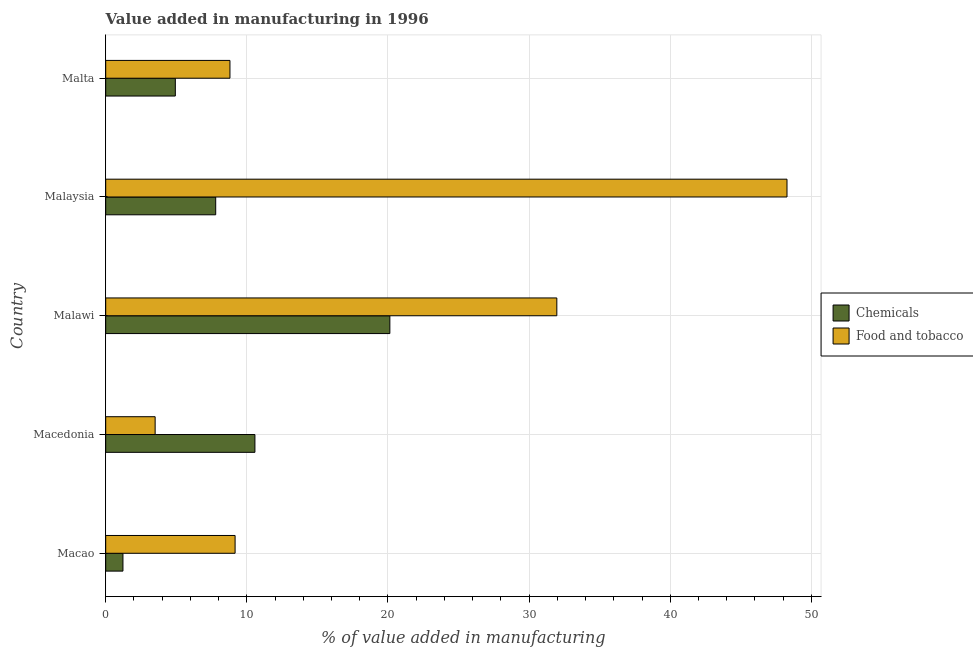How many different coloured bars are there?
Your answer should be compact. 2. How many bars are there on the 4th tick from the bottom?
Provide a succinct answer. 2. What is the label of the 1st group of bars from the top?
Offer a terse response. Malta. What is the value added by manufacturing food and tobacco in Malaysia?
Provide a short and direct response. 48.27. Across all countries, what is the maximum value added by manufacturing food and tobacco?
Provide a short and direct response. 48.27. Across all countries, what is the minimum value added by  manufacturing chemicals?
Your answer should be very brief. 1.22. In which country was the value added by manufacturing food and tobacco maximum?
Your answer should be compact. Malaysia. In which country was the value added by manufacturing food and tobacco minimum?
Offer a terse response. Macedonia. What is the total value added by manufacturing food and tobacco in the graph?
Give a very brief answer. 101.72. What is the difference between the value added by manufacturing food and tobacco in Macedonia and that in Malaysia?
Provide a succinct answer. -44.77. What is the difference between the value added by  manufacturing chemicals in Malta and the value added by manufacturing food and tobacco in Malawi?
Ensure brevity in your answer.  -27.03. What is the average value added by  manufacturing chemicals per country?
Offer a terse response. 8.93. What is the difference between the value added by  manufacturing chemicals and value added by manufacturing food and tobacco in Malawi?
Your answer should be very brief. -11.83. In how many countries, is the value added by  manufacturing chemicals greater than 30 %?
Offer a very short reply. 0. What is the ratio of the value added by  manufacturing chemicals in Macedonia to that in Malawi?
Keep it short and to the point. 0.53. Is the value added by manufacturing food and tobacco in Macedonia less than that in Malta?
Offer a very short reply. Yes. What is the difference between the highest and the second highest value added by  manufacturing chemicals?
Your answer should be very brief. 9.56. What is the difference between the highest and the lowest value added by manufacturing food and tobacco?
Make the answer very short. 44.77. What does the 2nd bar from the top in Malawi represents?
Provide a short and direct response. Chemicals. What does the 1st bar from the bottom in Malta represents?
Your response must be concise. Chemicals. How many bars are there?
Your answer should be compact. 10. What is the difference between two consecutive major ticks on the X-axis?
Your response must be concise. 10. Are the values on the major ticks of X-axis written in scientific E-notation?
Offer a very short reply. No. How are the legend labels stacked?
Keep it short and to the point. Vertical. What is the title of the graph?
Give a very brief answer. Value added in manufacturing in 1996. What is the label or title of the X-axis?
Ensure brevity in your answer.  % of value added in manufacturing. What is the % of value added in manufacturing in Chemicals in Macao?
Provide a succinct answer. 1.22. What is the % of value added in manufacturing in Food and tobacco in Macao?
Provide a succinct answer. 9.17. What is the % of value added in manufacturing of Chemicals in Macedonia?
Ensure brevity in your answer.  10.57. What is the % of value added in manufacturing in Food and tobacco in Macedonia?
Your response must be concise. 3.5. What is the % of value added in manufacturing of Chemicals in Malawi?
Keep it short and to the point. 20.13. What is the % of value added in manufacturing of Food and tobacco in Malawi?
Provide a short and direct response. 31.97. What is the % of value added in manufacturing of Chemicals in Malaysia?
Ensure brevity in your answer.  7.79. What is the % of value added in manufacturing in Food and tobacco in Malaysia?
Keep it short and to the point. 48.27. What is the % of value added in manufacturing of Chemicals in Malta?
Give a very brief answer. 4.93. What is the % of value added in manufacturing in Food and tobacco in Malta?
Your answer should be very brief. 8.8. Across all countries, what is the maximum % of value added in manufacturing of Chemicals?
Your answer should be very brief. 20.13. Across all countries, what is the maximum % of value added in manufacturing of Food and tobacco?
Your answer should be compact. 48.27. Across all countries, what is the minimum % of value added in manufacturing in Chemicals?
Offer a terse response. 1.22. Across all countries, what is the minimum % of value added in manufacturing in Food and tobacco?
Offer a terse response. 3.5. What is the total % of value added in manufacturing of Chemicals in the graph?
Make the answer very short. 44.66. What is the total % of value added in manufacturing of Food and tobacco in the graph?
Your answer should be compact. 101.72. What is the difference between the % of value added in manufacturing in Chemicals in Macao and that in Macedonia?
Your response must be concise. -9.35. What is the difference between the % of value added in manufacturing of Food and tobacco in Macao and that in Macedonia?
Your answer should be compact. 5.67. What is the difference between the % of value added in manufacturing of Chemicals in Macao and that in Malawi?
Ensure brevity in your answer.  -18.91. What is the difference between the % of value added in manufacturing of Food and tobacco in Macao and that in Malawi?
Offer a terse response. -22.8. What is the difference between the % of value added in manufacturing in Chemicals in Macao and that in Malaysia?
Offer a very short reply. -6.57. What is the difference between the % of value added in manufacturing of Food and tobacco in Macao and that in Malaysia?
Offer a very short reply. -39.11. What is the difference between the % of value added in manufacturing of Chemicals in Macao and that in Malta?
Your answer should be compact. -3.71. What is the difference between the % of value added in manufacturing in Food and tobacco in Macao and that in Malta?
Your answer should be compact. 0.36. What is the difference between the % of value added in manufacturing of Chemicals in Macedonia and that in Malawi?
Provide a succinct answer. -9.56. What is the difference between the % of value added in manufacturing of Food and tobacco in Macedonia and that in Malawi?
Your answer should be very brief. -28.46. What is the difference between the % of value added in manufacturing in Chemicals in Macedonia and that in Malaysia?
Your response must be concise. 2.78. What is the difference between the % of value added in manufacturing of Food and tobacco in Macedonia and that in Malaysia?
Offer a terse response. -44.77. What is the difference between the % of value added in manufacturing of Chemicals in Macedonia and that in Malta?
Offer a very short reply. 5.64. What is the difference between the % of value added in manufacturing in Food and tobacco in Macedonia and that in Malta?
Offer a very short reply. -5.3. What is the difference between the % of value added in manufacturing of Chemicals in Malawi and that in Malaysia?
Give a very brief answer. 12.34. What is the difference between the % of value added in manufacturing in Food and tobacco in Malawi and that in Malaysia?
Provide a short and direct response. -16.31. What is the difference between the % of value added in manufacturing of Chemicals in Malawi and that in Malta?
Your answer should be very brief. 15.2. What is the difference between the % of value added in manufacturing of Food and tobacco in Malawi and that in Malta?
Provide a succinct answer. 23.16. What is the difference between the % of value added in manufacturing of Chemicals in Malaysia and that in Malta?
Offer a terse response. 2.86. What is the difference between the % of value added in manufacturing in Food and tobacco in Malaysia and that in Malta?
Your response must be concise. 39.47. What is the difference between the % of value added in manufacturing of Chemicals in Macao and the % of value added in manufacturing of Food and tobacco in Macedonia?
Offer a very short reply. -2.28. What is the difference between the % of value added in manufacturing of Chemicals in Macao and the % of value added in manufacturing of Food and tobacco in Malawi?
Provide a short and direct response. -30.74. What is the difference between the % of value added in manufacturing in Chemicals in Macao and the % of value added in manufacturing in Food and tobacco in Malaysia?
Offer a very short reply. -47.05. What is the difference between the % of value added in manufacturing of Chemicals in Macao and the % of value added in manufacturing of Food and tobacco in Malta?
Keep it short and to the point. -7.58. What is the difference between the % of value added in manufacturing in Chemicals in Macedonia and the % of value added in manufacturing in Food and tobacco in Malawi?
Ensure brevity in your answer.  -21.39. What is the difference between the % of value added in manufacturing of Chemicals in Macedonia and the % of value added in manufacturing of Food and tobacco in Malaysia?
Your answer should be compact. -37.7. What is the difference between the % of value added in manufacturing in Chemicals in Macedonia and the % of value added in manufacturing in Food and tobacco in Malta?
Provide a short and direct response. 1.77. What is the difference between the % of value added in manufacturing in Chemicals in Malawi and the % of value added in manufacturing in Food and tobacco in Malaysia?
Give a very brief answer. -28.14. What is the difference between the % of value added in manufacturing in Chemicals in Malawi and the % of value added in manufacturing in Food and tobacco in Malta?
Keep it short and to the point. 11.33. What is the difference between the % of value added in manufacturing of Chemicals in Malaysia and the % of value added in manufacturing of Food and tobacco in Malta?
Make the answer very short. -1.01. What is the average % of value added in manufacturing in Chemicals per country?
Keep it short and to the point. 8.93. What is the average % of value added in manufacturing in Food and tobacco per country?
Make the answer very short. 20.34. What is the difference between the % of value added in manufacturing of Chemicals and % of value added in manufacturing of Food and tobacco in Macao?
Keep it short and to the point. -7.95. What is the difference between the % of value added in manufacturing of Chemicals and % of value added in manufacturing of Food and tobacco in Macedonia?
Keep it short and to the point. 7.07. What is the difference between the % of value added in manufacturing of Chemicals and % of value added in manufacturing of Food and tobacco in Malawi?
Provide a succinct answer. -11.83. What is the difference between the % of value added in manufacturing in Chemicals and % of value added in manufacturing in Food and tobacco in Malaysia?
Keep it short and to the point. -40.48. What is the difference between the % of value added in manufacturing of Chemicals and % of value added in manufacturing of Food and tobacco in Malta?
Keep it short and to the point. -3.87. What is the ratio of the % of value added in manufacturing of Chemicals in Macao to that in Macedonia?
Offer a very short reply. 0.12. What is the ratio of the % of value added in manufacturing of Food and tobacco in Macao to that in Macedonia?
Offer a very short reply. 2.62. What is the ratio of the % of value added in manufacturing of Chemicals in Macao to that in Malawi?
Make the answer very short. 0.06. What is the ratio of the % of value added in manufacturing of Food and tobacco in Macao to that in Malawi?
Provide a short and direct response. 0.29. What is the ratio of the % of value added in manufacturing in Chemicals in Macao to that in Malaysia?
Your answer should be compact. 0.16. What is the ratio of the % of value added in manufacturing of Food and tobacco in Macao to that in Malaysia?
Your answer should be compact. 0.19. What is the ratio of the % of value added in manufacturing of Chemicals in Macao to that in Malta?
Provide a succinct answer. 0.25. What is the ratio of the % of value added in manufacturing in Food and tobacco in Macao to that in Malta?
Provide a succinct answer. 1.04. What is the ratio of the % of value added in manufacturing in Chemicals in Macedonia to that in Malawi?
Your answer should be compact. 0.53. What is the ratio of the % of value added in manufacturing of Food and tobacco in Macedonia to that in Malawi?
Offer a very short reply. 0.11. What is the ratio of the % of value added in manufacturing in Chemicals in Macedonia to that in Malaysia?
Your answer should be compact. 1.36. What is the ratio of the % of value added in manufacturing of Food and tobacco in Macedonia to that in Malaysia?
Your answer should be compact. 0.07. What is the ratio of the % of value added in manufacturing in Chemicals in Macedonia to that in Malta?
Your answer should be very brief. 2.14. What is the ratio of the % of value added in manufacturing of Food and tobacco in Macedonia to that in Malta?
Offer a terse response. 0.4. What is the ratio of the % of value added in manufacturing in Chemicals in Malawi to that in Malaysia?
Your response must be concise. 2.58. What is the ratio of the % of value added in manufacturing in Food and tobacco in Malawi to that in Malaysia?
Make the answer very short. 0.66. What is the ratio of the % of value added in manufacturing in Chemicals in Malawi to that in Malta?
Provide a succinct answer. 4.08. What is the ratio of the % of value added in manufacturing of Food and tobacco in Malawi to that in Malta?
Your answer should be compact. 3.63. What is the ratio of the % of value added in manufacturing of Chemicals in Malaysia to that in Malta?
Provide a succinct answer. 1.58. What is the ratio of the % of value added in manufacturing in Food and tobacco in Malaysia to that in Malta?
Make the answer very short. 5.48. What is the difference between the highest and the second highest % of value added in manufacturing in Chemicals?
Offer a very short reply. 9.56. What is the difference between the highest and the second highest % of value added in manufacturing of Food and tobacco?
Offer a terse response. 16.31. What is the difference between the highest and the lowest % of value added in manufacturing of Chemicals?
Offer a very short reply. 18.91. What is the difference between the highest and the lowest % of value added in manufacturing in Food and tobacco?
Make the answer very short. 44.77. 